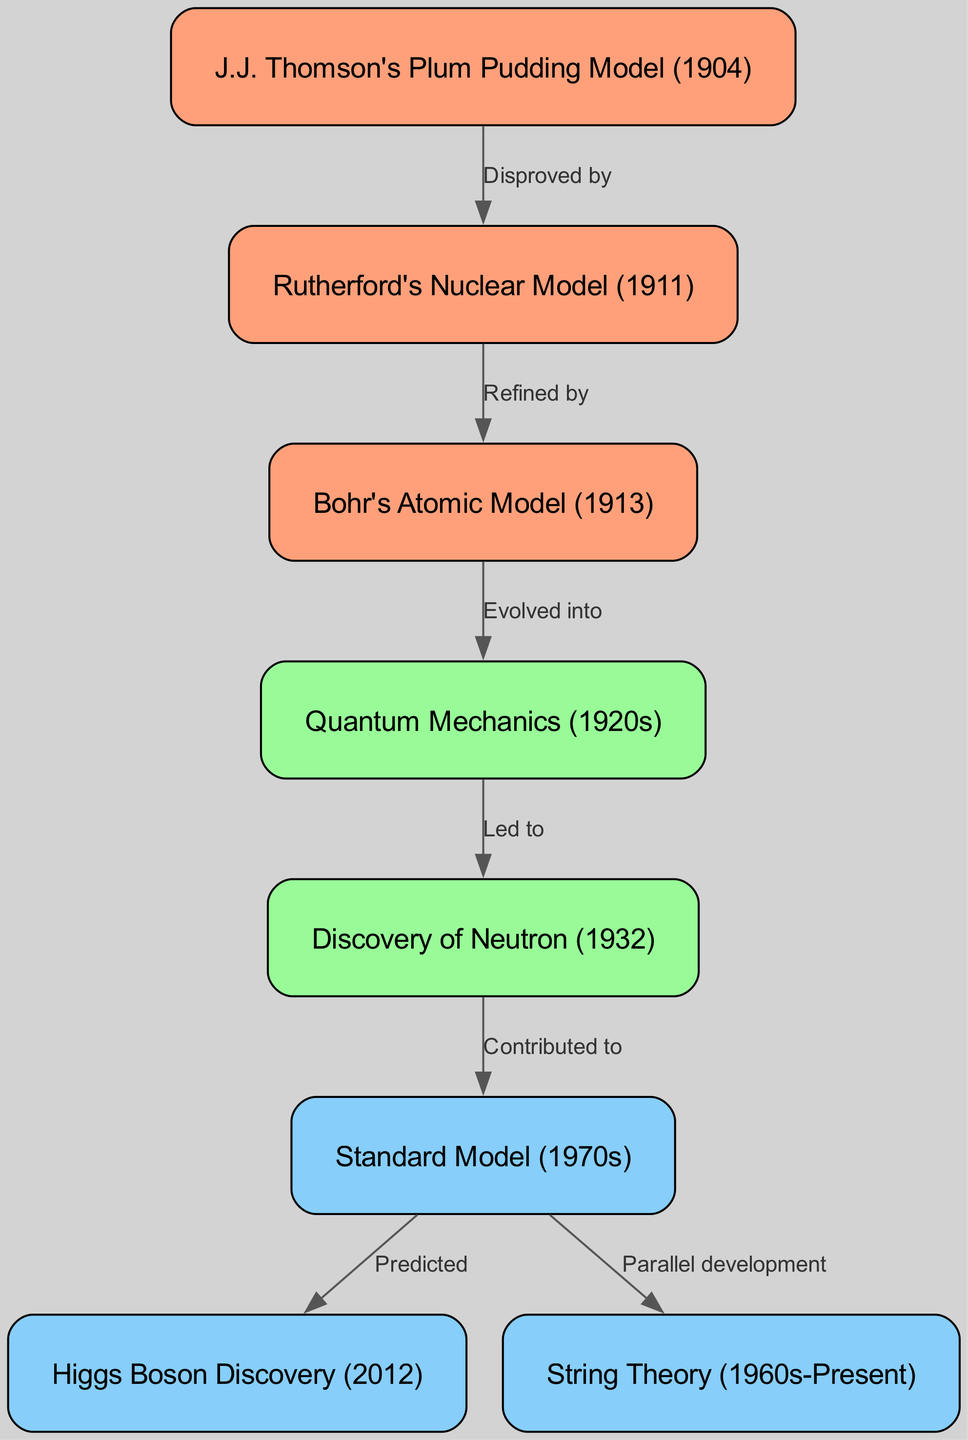What is the first model in the diagram? The diagram lists J.J. Thomson's Plum Pudding Model as the first element (node) at the top, indicated by the ID "1".
Answer: J.J. Thomson's Plum Pudding Model (1904) How many nodes are in the diagram? By counting the distinct models represented in the nodes section, there are eight separate models listed, which are all part of the evolution of subatomic particle theories.
Answer: 8 What theory directly follows Rutherford's Nuclear Model? Following the Rutherford's Nuclear Model, indicated by the edge labeled "Refined by", is Bohr's Atomic Model, showing progression in theories about atomic structure.
Answer: Bohr's Atomic Model (1913) Which theory led to the discovery of the neutron? The progression from Quantum Mechanics leads directly to the Discovery of the Neutron, indicated by the edge labeled "Led to", which connects Quantum Mechanics to the neutron's discovery.
Answer: Discovery of Neutron (1932) What does the Standard Model predict according to the graph? According to the diagram, the Standard Model predicts the Higgs Boson Discovery, as indicated by the edge labeled "Predicted" connecting the Standard Model to Higgs Boson Discovery.
Answer: Higgs Boson Discovery (2012) What are the key periods associated with String Theory? String Theory is noted in the diagram as having a significant time range from the 1960s to the present, indicating its ongoing development alongside other theories.
Answer: 1960s-Present How many connections (edges) are shown in the diagram? The visual representation demonstrates seven distinct connections between the theories, which indicates the evolution and relationships between them throughout history.
Answer: 7 What is common between the Standard Model and String Theory in the diagram? Both theories share a characteristic of parallel development, as indicated by the edge connecting the Standard Model to String Theory with a label of "Parallel development".
Answer: Parallel development What does Quantum Mechanics lead to? The edge labeled "Led to" indicates that Quantum Mechanics directly leads to the Discovery of Neutron, emphasizing its influence on later discoveries in particle physics.
Answer: Discovery of Neutron (1932) 